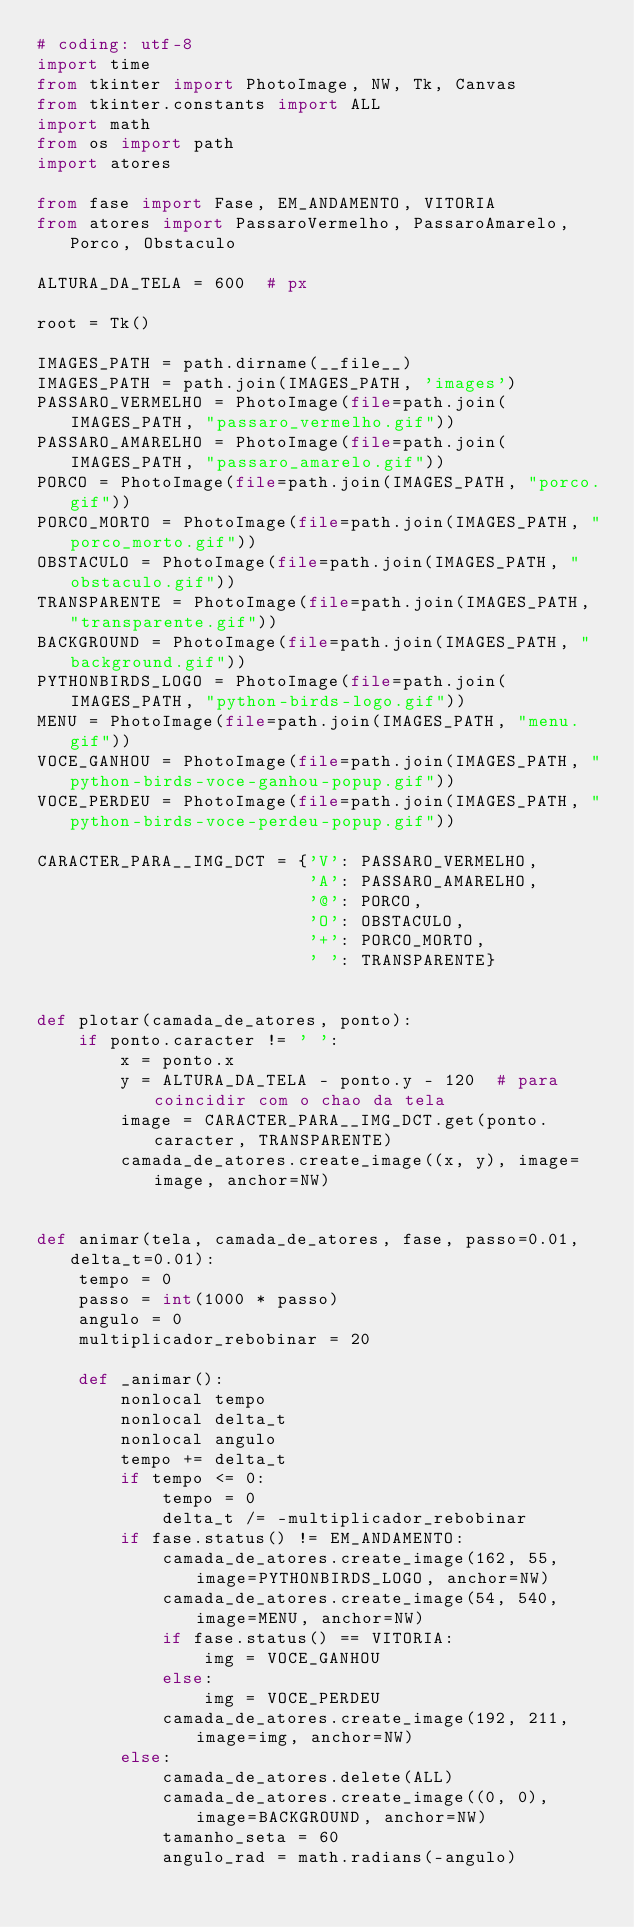Convert code to text. <code><loc_0><loc_0><loc_500><loc_500><_Python_># coding: utf-8
import time
from tkinter import PhotoImage, NW, Tk, Canvas
from tkinter.constants import ALL
import math
from os import path
import atores

from fase import Fase, EM_ANDAMENTO, VITORIA
from atores import PassaroVermelho, PassaroAmarelo, Porco, Obstaculo

ALTURA_DA_TELA = 600  # px

root = Tk()

IMAGES_PATH = path.dirname(__file__)
IMAGES_PATH = path.join(IMAGES_PATH, 'images')
PASSARO_VERMELHO = PhotoImage(file=path.join(IMAGES_PATH, "passaro_vermelho.gif"))
PASSARO_AMARELHO = PhotoImage(file=path.join(IMAGES_PATH, "passaro_amarelo.gif"))
PORCO = PhotoImage(file=path.join(IMAGES_PATH, "porco.gif"))
PORCO_MORTO = PhotoImage(file=path.join(IMAGES_PATH, "porco_morto.gif"))
OBSTACULO = PhotoImage(file=path.join(IMAGES_PATH, "obstaculo.gif"))
TRANSPARENTE = PhotoImage(file=path.join(IMAGES_PATH, "transparente.gif"))
BACKGROUND = PhotoImage(file=path.join(IMAGES_PATH, "background.gif"))
PYTHONBIRDS_LOGO = PhotoImage(file=path.join(IMAGES_PATH, "python-birds-logo.gif"))
MENU = PhotoImage(file=path.join(IMAGES_PATH, "menu.gif"))
VOCE_GANHOU = PhotoImage(file=path.join(IMAGES_PATH, "python-birds-voce-ganhou-popup.gif"))
VOCE_PERDEU = PhotoImage(file=path.join(IMAGES_PATH, "python-birds-voce-perdeu-popup.gif"))

CARACTER_PARA__IMG_DCT = {'V': PASSARO_VERMELHO,
                          'A': PASSARO_AMARELHO,
                          '@': PORCO,
                          'O': OBSTACULO,
                          '+': PORCO_MORTO,
                          ' ': TRANSPARENTE}


def plotar(camada_de_atores, ponto):
    if ponto.caracter != ' ':
        x = ponto.x
        y = ALTURA_DA_TELA - ponto.y - 120  # para coincidir com o chao da tela
        image = CARACTER_PARA__IMG_DCT.get(ponto.caracter, TRANSPARENTE)
        camada_de_atores.create_image((x, y), image=image, anchor=NW)


def animar(tela, camada_de_atores, fase, passo=0.01, delta_t=0.01):
    tempo = 0
    passo = int(1000 * passo)
    angulo = 0
    multiplicador_rebobinar = 20

    def _animar():
        nonlocal tempo
        nonlocal delta_t
        nonlocal angulo
        tempo += delta_t
        if tempo <= 0:
            tempo = 0
            delta_t /= -multiplicador_rebobinar
        if fase.status() != EM_ANDAMENTO:
            camada_de_atores.create_image(162, 55, image=PYTHONBIRDS_LOGO, anchor=NW)
            camada_de_atores.create_image(54, 540, image=MENU, anchor=NW)
            if fase.status() == VITORIA:
                img = VOCE_GANHOU
            else:
                img = VOCE_PERDEU
            camada_de_atores.create_image(192, 211, image=img, anchor=NW)
        else:
            camada_de_atores.delete(ALL)
            camada_de_atores.create_image((0, 0), image=BACKGROUND, anchor=NW)
            tamanho_seta = 60
            angulo_rad = math.radians(-angulo)
</code> 